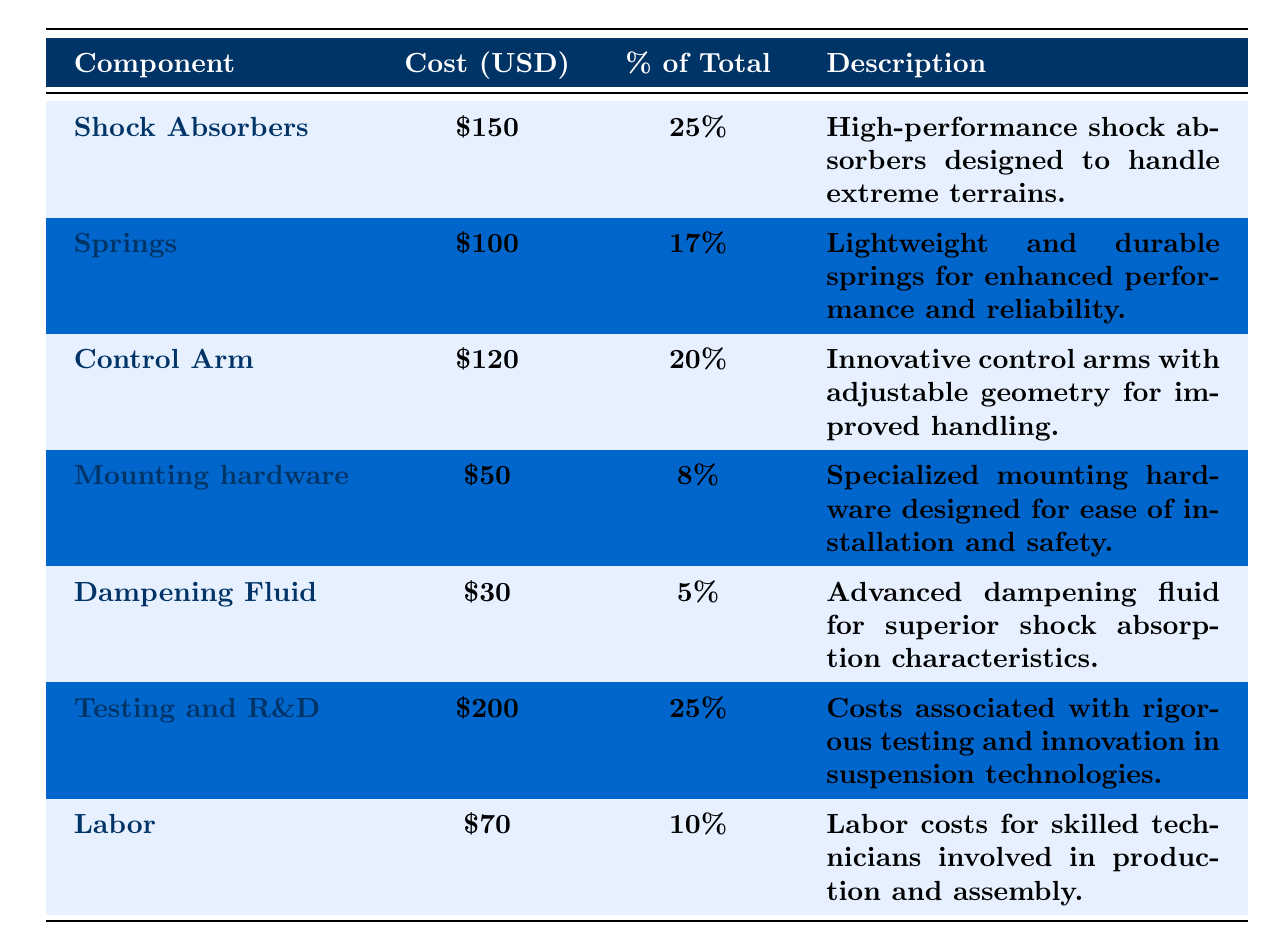What's the cost of the Shock Absorbers? The table indicates that the cost listed for Shock Absorbers is \$150.
Answer: 150 What percentage of the total cost does the Springs represent? According to the table, Springs account for 17% of the total cost.
Answer: 17% Which component has the highest individual cost? The Testing and R&D component has the highest cost at \$200, as indicated in the table.
Answer: Testing and R&D Is the cost of Dampening Fluid less than ten percent of the total costs? The table shows that Dampening Fluid costs \$30, which is 5% of the total cost, confirming it is indeed less than ten percent.
Answer: Yes What is the total cost of Labor and Mounting Hardware combined? Labor costs \$70, while Mounting Hardware costs \$50. Adding these together gives \$70 + \$50 = \$120.
Answer: 120 Which two components together account for exactly 42% of the total cost? The combination of Springs (17%) and Control Arm (20%) together adds up to 37% (17% + 20%). However, the correct pair is Shock Absorbers (25%) and Labor (10%), which equals 35%. This means no two components exactly meet this requirement, so none is found.
Answer: None Calculate the average cost of all components listed. The total cost is \$150 + \$100 + \$120 + \$50 + \$30 + \$200 + \$70 = \$820. There are 7 components, so the average cost is \$820 / 7 = \$117.14.
Answer: 117.14 What component makes up exactly 25% of total production costs? The components that make up 25% of the total costs, as shown in the table, are Shock Absorbers and Testing and R&D.
Answer: Shock Absorbers, Testing and R&D Which two components contribute the least to the total cost in terms of percentage? The Dampening Fluid (5%) and Mounting Hardware (8%) have the lowest percentages of total costs respectively, which sum up to 13%.
Answer: Dampening Fluid and Mounting Hardware Is the cost of Testing and R&D equal to the combined cost of Shock Absorbers and Control Arm? Shock Absorbers cost \$150 and Control Arm costs \$120, adding up to \$270. Testing and R&D stands at \$200. Since \$270 is greater than \$200, the statement is false.
Answer: No 